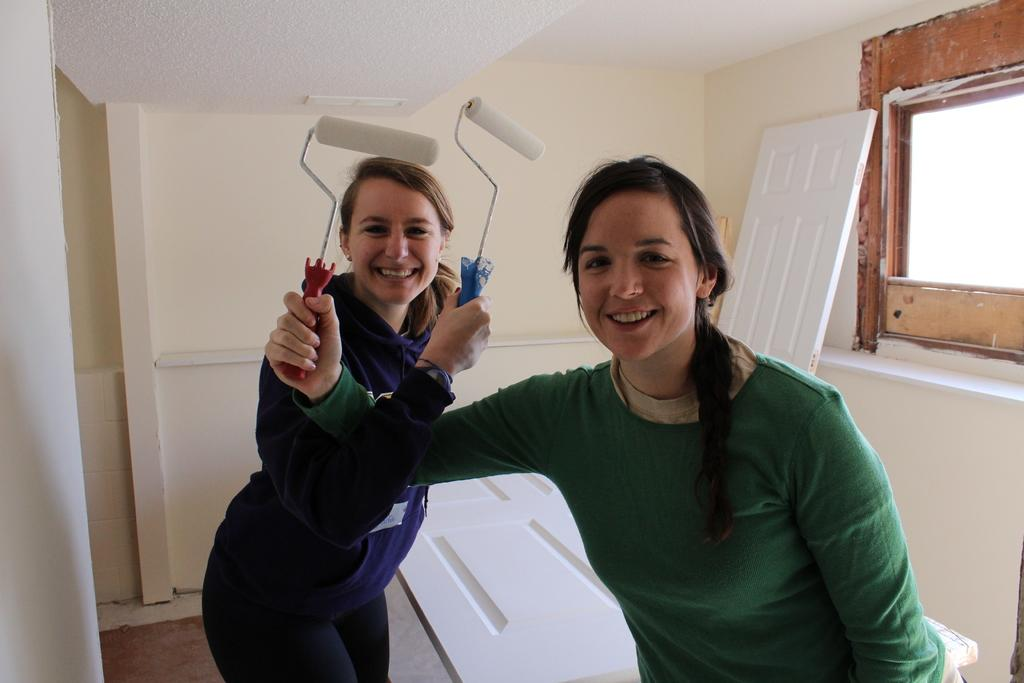How many people are in the image? There are two women in the image. What are the women wearing? The women are wearing clothes. What expression do the women have? The women are smiling. What are the women holding in their hands? The women are holding roll paint brushes in their hands. What can be seen in the background of the image? There is a wall and a window in the image. What type of cream can be seen on the wall in the image? There is no cream visible on the wall in the image; the women are holding roll paint brushes, which suggests they might be painting the wall. How many cattle are present in the image? There are no cattle present in the image. 